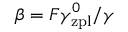Convert formula to latex. <formula><loc_0><loc_0><loc_500><loc_500>\beta = F \gamma _ { z p l } ^ { 0 } / \gamma</formula> 